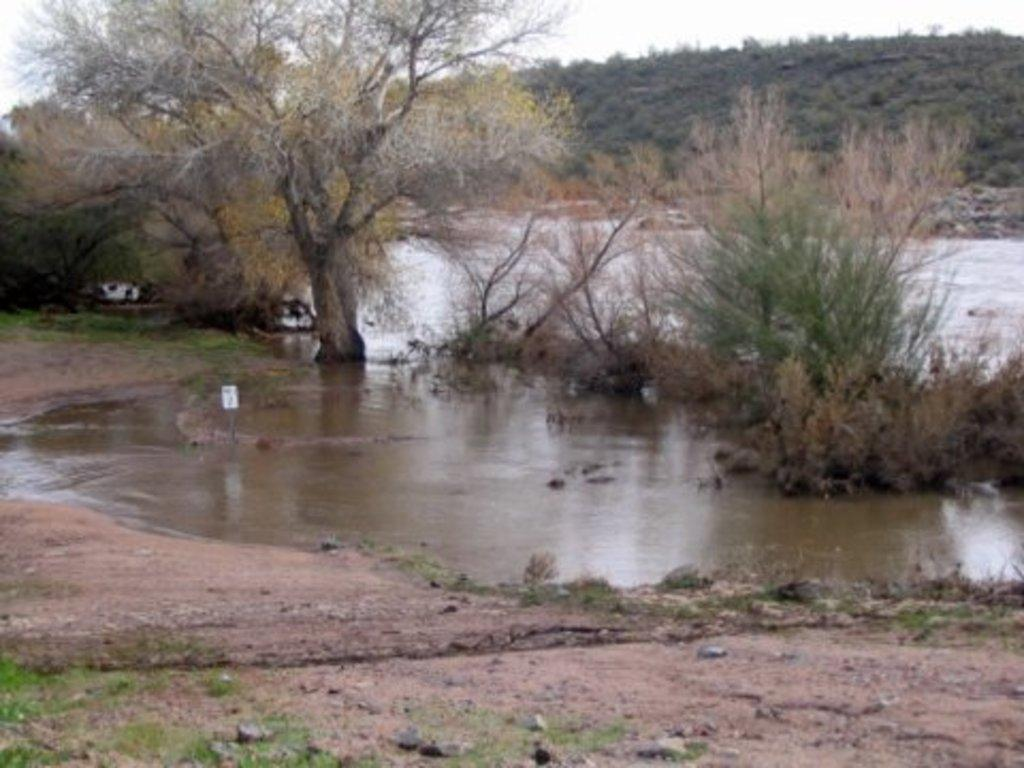What type of natural elements can be seen on the ground in the image? There are stones on the ground in the image. What else is visible besides the stones on the ground? There is water visible in the image. What type of vegetation can be seen in the image? There are trees and plants in the image. What can be seen in the background of the image? The sky is visible in the background of the image. What type of arch can be seen in the image? There is no arch present in the image. How many hands are visible in the image? There are no hands visible in the image. 